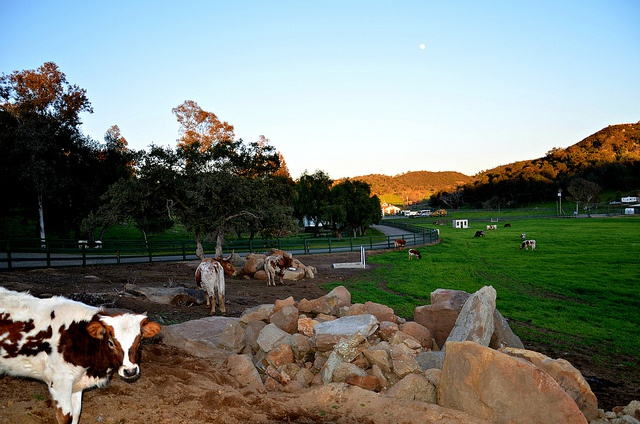Describe the objects in this image and their specific colors. I can see cow in lightblue, lightgray, black, and maroon tones, cow in lightblue, darkgray, black, gray, and maroon tones, cow in lightblue, black, gray, maroon, and darkgray tones, cow in lightblue, black, gray, and darkgray tones, and cow in lightblue, black, gray, maroon, and darkgray tones in this image. 